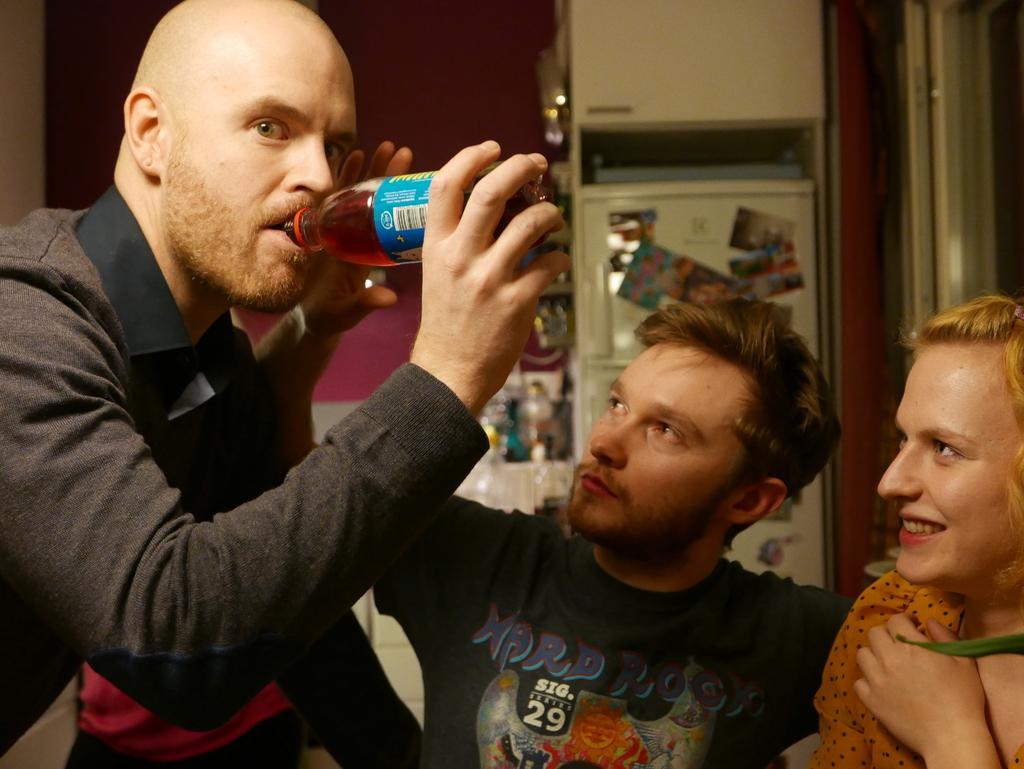Describe this image in one or two sentences. In this picture we can see a man drinking coke from the bottle and looking at the camera. Beside we can see a man and a woman sitting and looking at him. Behind we can see the white iron box and a purple wall.  